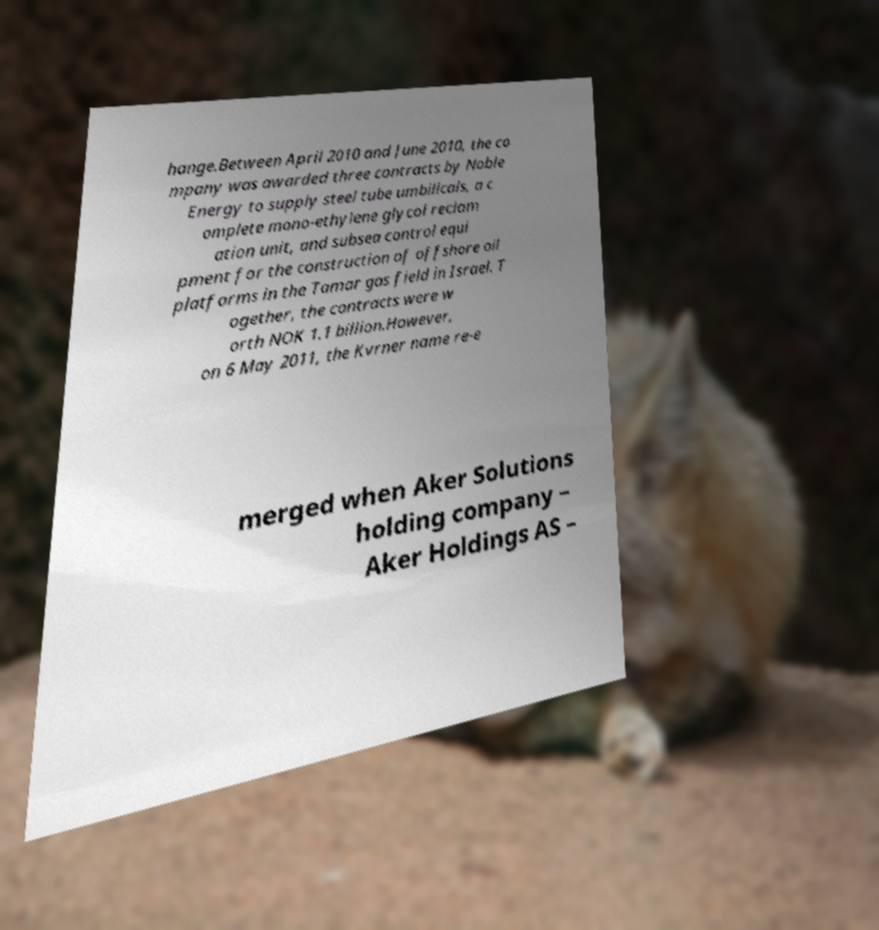Could you extract and type out the text from this image? hange.Between April 2010 and June 2010, the co mpany was awarded three contracts by Noble Energy to supply steel tube umbilicals, a c omplete mono-ethylene glycol reclam ation unit, and subsea control equi pment for the construction of offshore oil platforms in the Tamar gas field in Israel. T ogether, the contracts were w orth NOK 1.1 billion.However, on 6 May 2011, the Kvrner name re-e merged when Aker Solutions holding company – Aker Holdings AS – 